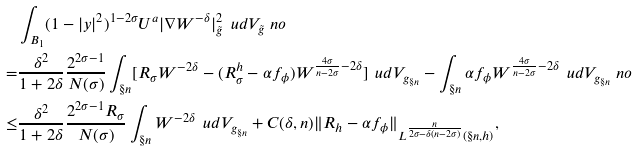Convert formula to latex. <formula><loc_0><loc_0><loc_500><loc_500>& \int _ { B _ { 1 } } ( 1 - | y | ^ { 2 } ) ^ { 1 - 2 \sigma } U ^ { a } | \nabla W ^ { - \delta } | _ { \tilde { g } } ^ { 2 } \, \ u d V _ { \tilde { g } } \ n o \\ = & \frac { \delta ^ { 2 } } { 1 + 2 \delta } \frac { 2 ^ { 2 \sigma - 1 } } { N ( \sigma ) } \int _ { \S n } [ R _ { \sigma } W ^ { - 2 \delta } - ( R _ { \sigma } ^ { h } - \alpha f _ { \phi } ) W ^ { \frac { 4 \sigma } { n - 2 \sigma } - 2 \delta } ] \, \ u d V _ { g _ { \S n } } - \int _ { \S n } \alpha f _ { \phi } W ^ { \frac { 4 \sigma } { n - 2 \sigma } - 2 \delta } \, \ u d V _ { g _ { \S n } } \ n o \\ \leq & \frac { \delta ^ { 2 } } { 1 + 2 \delta } \frac { 2 ^ { 2 \sigma - 1 } R _ { \sigma } } { N ( \sigma ) } \int _ { \S n } W ^ { - 2 \delta } \, \ u d V _ { g _ { \S n } } + C ( \delta , n ) \| R _ { h } - \alpha f _ { \phi } \| _ { L ^ { \frac { n } { 2 \sigma - \delta ( n - 2 \sigma ) } } ( \S n , h ) } ,</formula> 